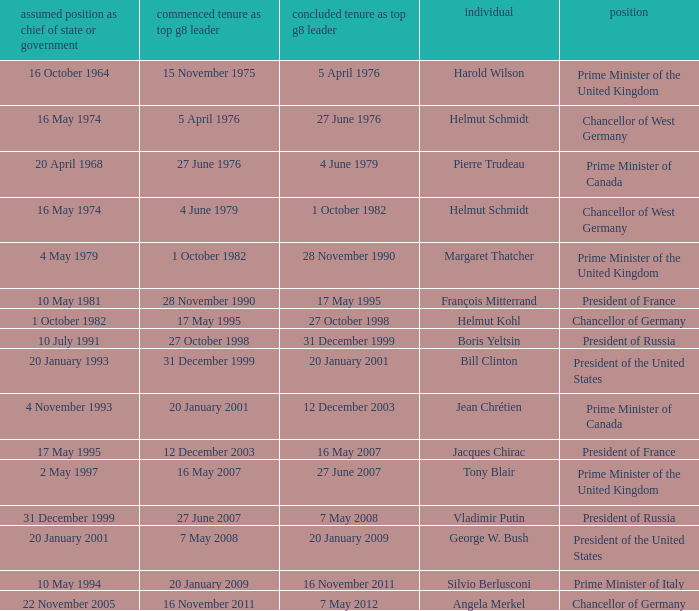When did Jacques Chirac stop being a G8 leader? 16 May 2007. 